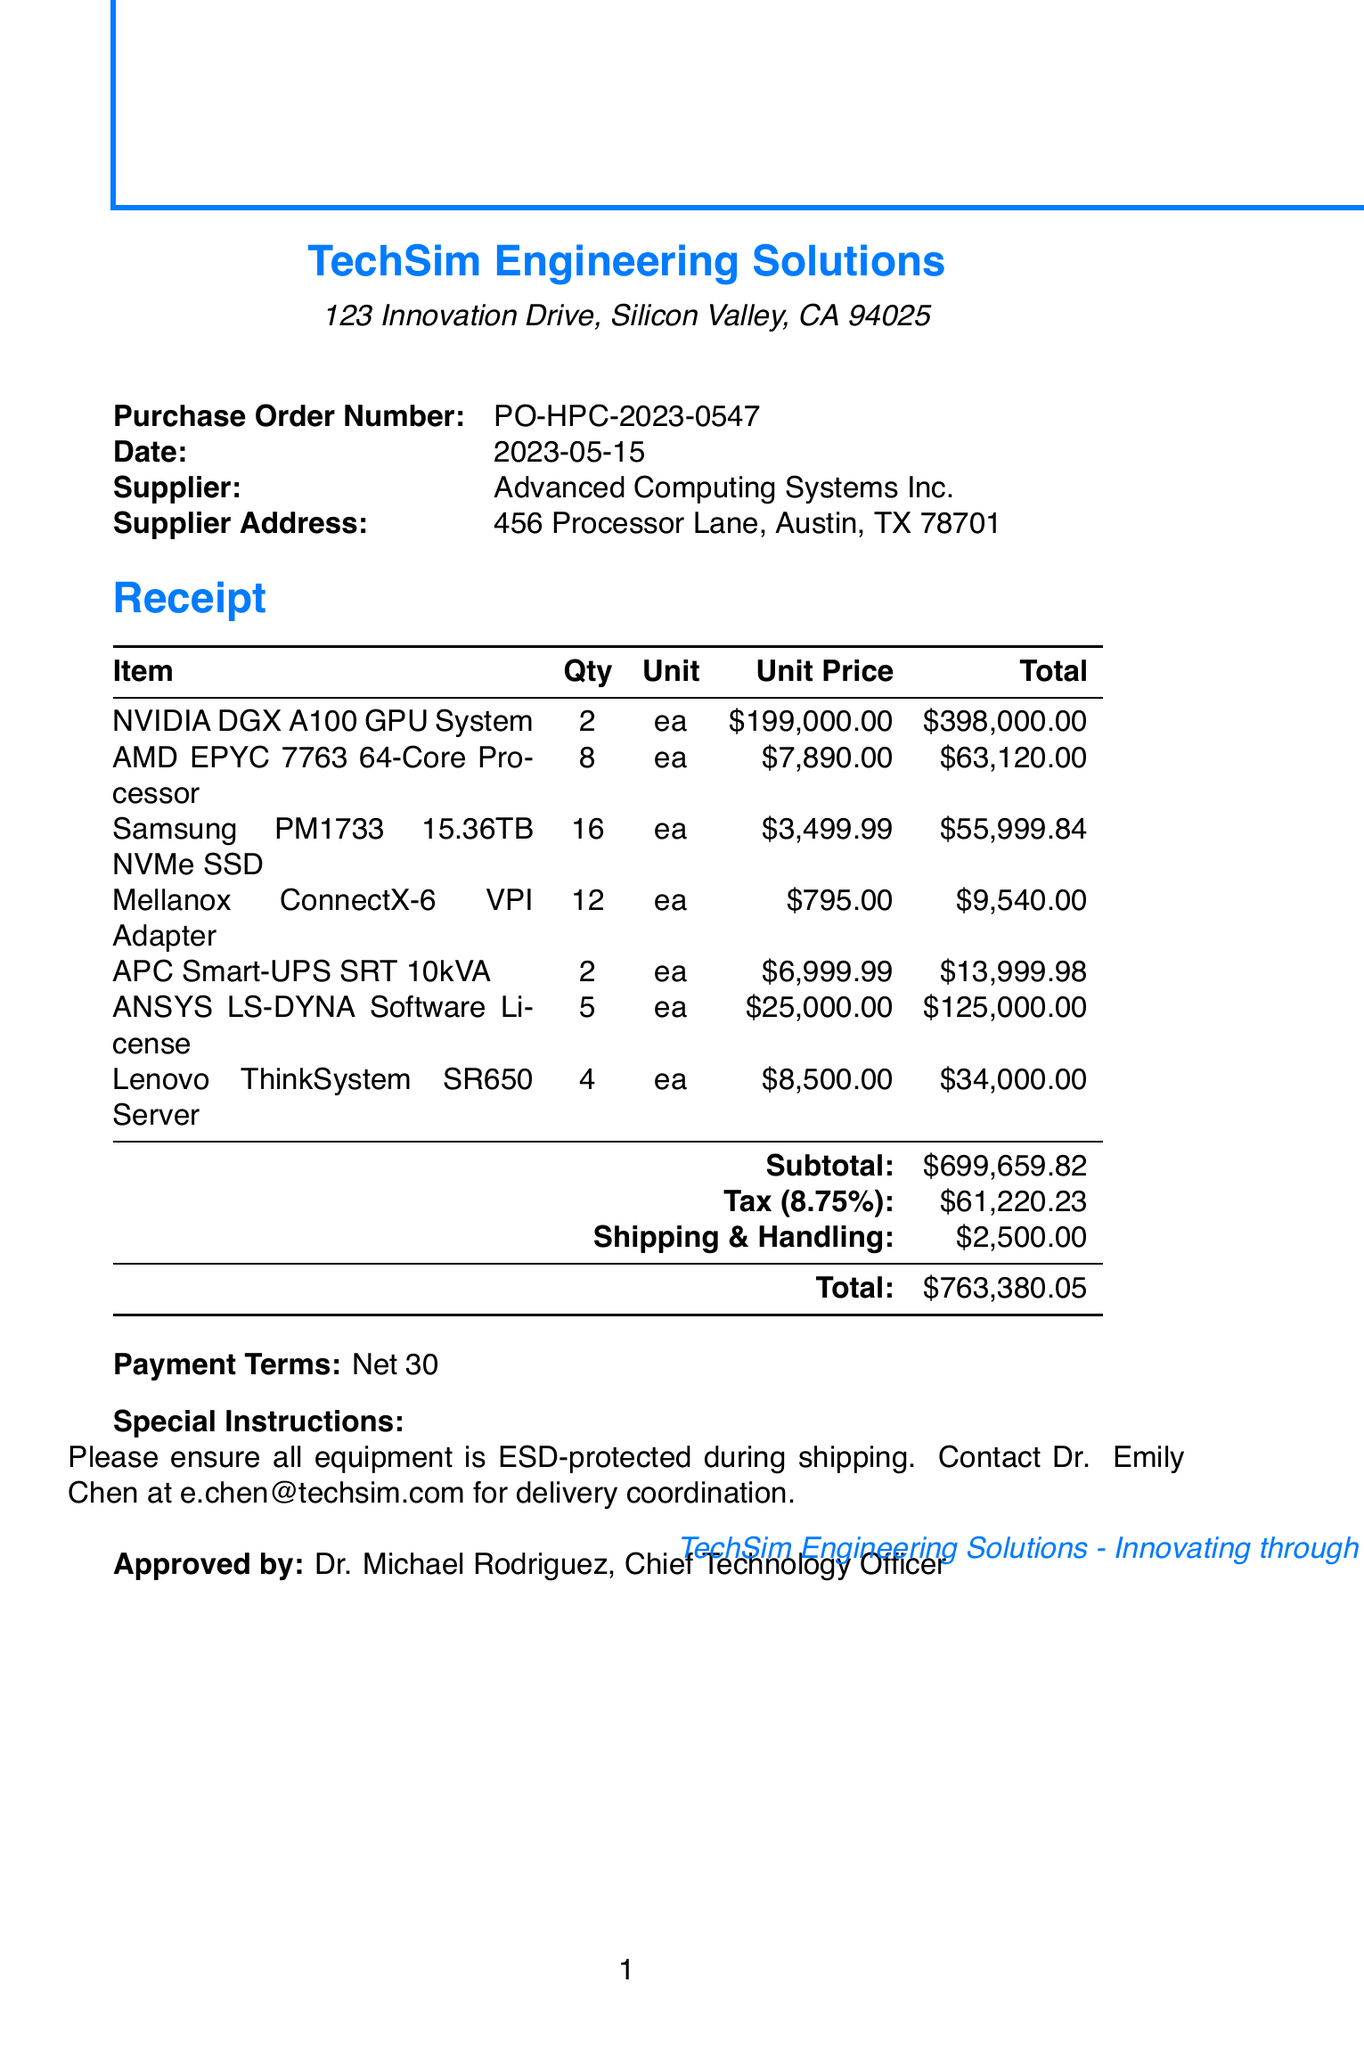What is the company name? The company name listed on the receipt is "TechSim Engineering Solutions."
Answer: TechSim Engineering Solutions What is the purchase order number? The purchase order number is specifically stated in the document as "PO-HPC-2023-0547."
Answer: PO-HPC-2023-0547 How many NVIDIA DGX A100 GPU Systems were purchased? The receipt indicates that 2 units of the NVIDIA DGX A100 GPU System were purchased.
Answer: 2 What is the total amount of tax? The total amount of tax is explicitly mentioned in the document as $61,220.23.
Answer: $61,220.23 Who approved the purchase order? The document states that the approval was given by Dr. Michael Rodriguez, who is the Chief Technology Officer.
Answer: Dr. Michael Rodriguez What is the unit price of the Samsung PM1733 15.36TB NVMe SSD? The unit price of the Samsung PM1733 15.36TB NVMe SSD is listed as $3,499.99.
Answer: $3,499.99 What is the subtotal for all items? The subtotal for all items before taxes and shipping is provided as $699,659.82.
Answer: $699,659.82 What is the shipping and handling fee? The shipping and handling fee is mentioned as $2,500.00 in the document.
Answer: $2,500.00 What special instruction is provided? The document instructs to ensure all equipment is ESD-protected during shipping.
Answer: ESD-protected during shipping 